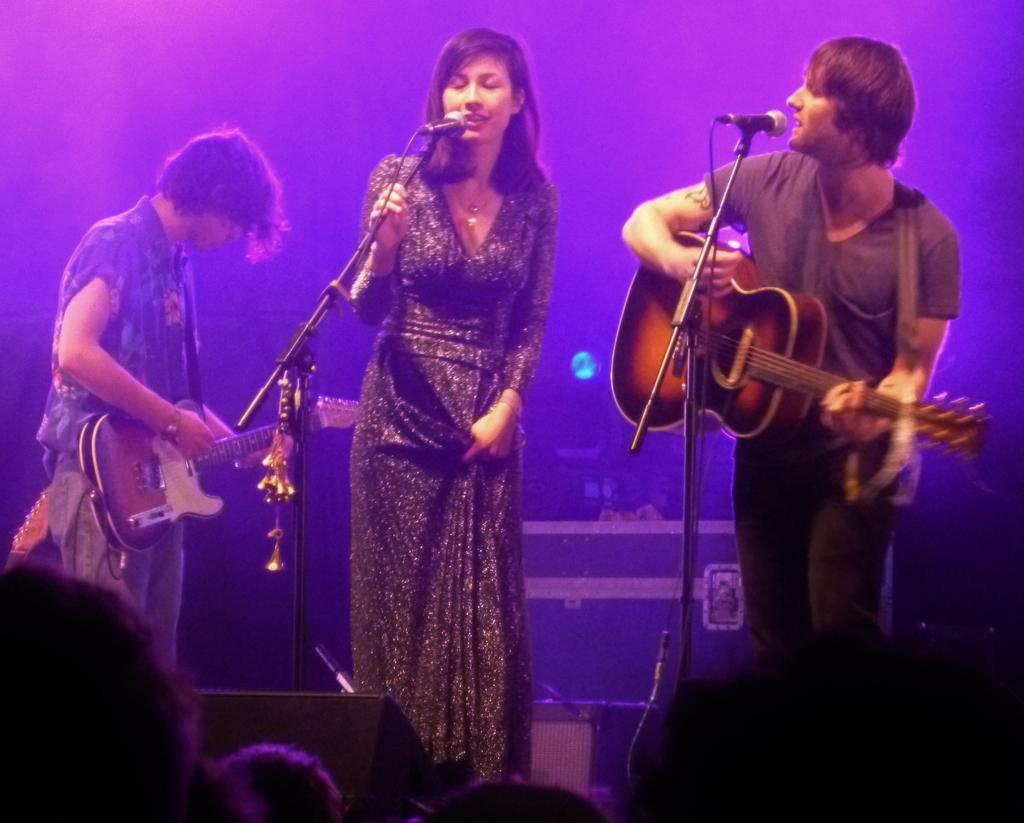Who is the main subject in the image? There is a woman in the image. Where is the woman positioned in the image? The woman is standing in the middle. What is the woman holding in the image? The woman is holding a microphone. Can you describe the person at the right side of the image? The person at the right side is holding and playing a guitar. What is the position of the person at the left side of the image? The person at the left side is standing. What type of ear is visible on the woman in the image? There is no ear visible on the woman in the image; she is holding a microphone. What type of competition is taking place in the image? There is no competition present in the image; it features a woman holding a microphone and two people playing musical instruments. 